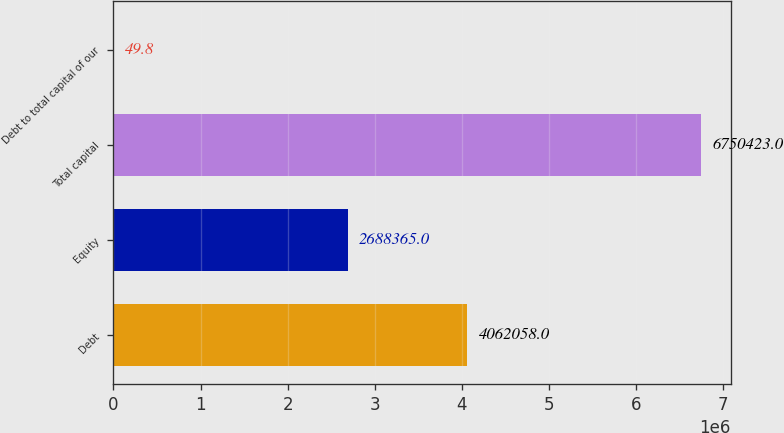<chart> <loc_0><loc_0><loc_500><loc_500><bar_chart><fcel>Debt<fcel>Equity<fcel>Total capital<fcel>Debt to total capital of our<nl><fcel>4.06206e+06<fcel>2.68836e+06<fcel>6.75042e+06<fcel>49.8<nl></chart> 